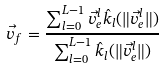Convert formula to latex. <formula><loc_0><loc_0><loc_500><loc_500>\vec { v } _ { f } = \frac { \sum _ { l = 0 } ^ { L - 1 } \vec { v } _ { e } ^ { l } \hat { k } _ { l } ( \| \vec { v } _ { e } ^ { l } \| ) } { \sum _ { l = 0 } ^ { L - 1 } \hat { k } _ { l } ( \| \vec { v } _ { e } ^ { l } \| ) }</formula> 